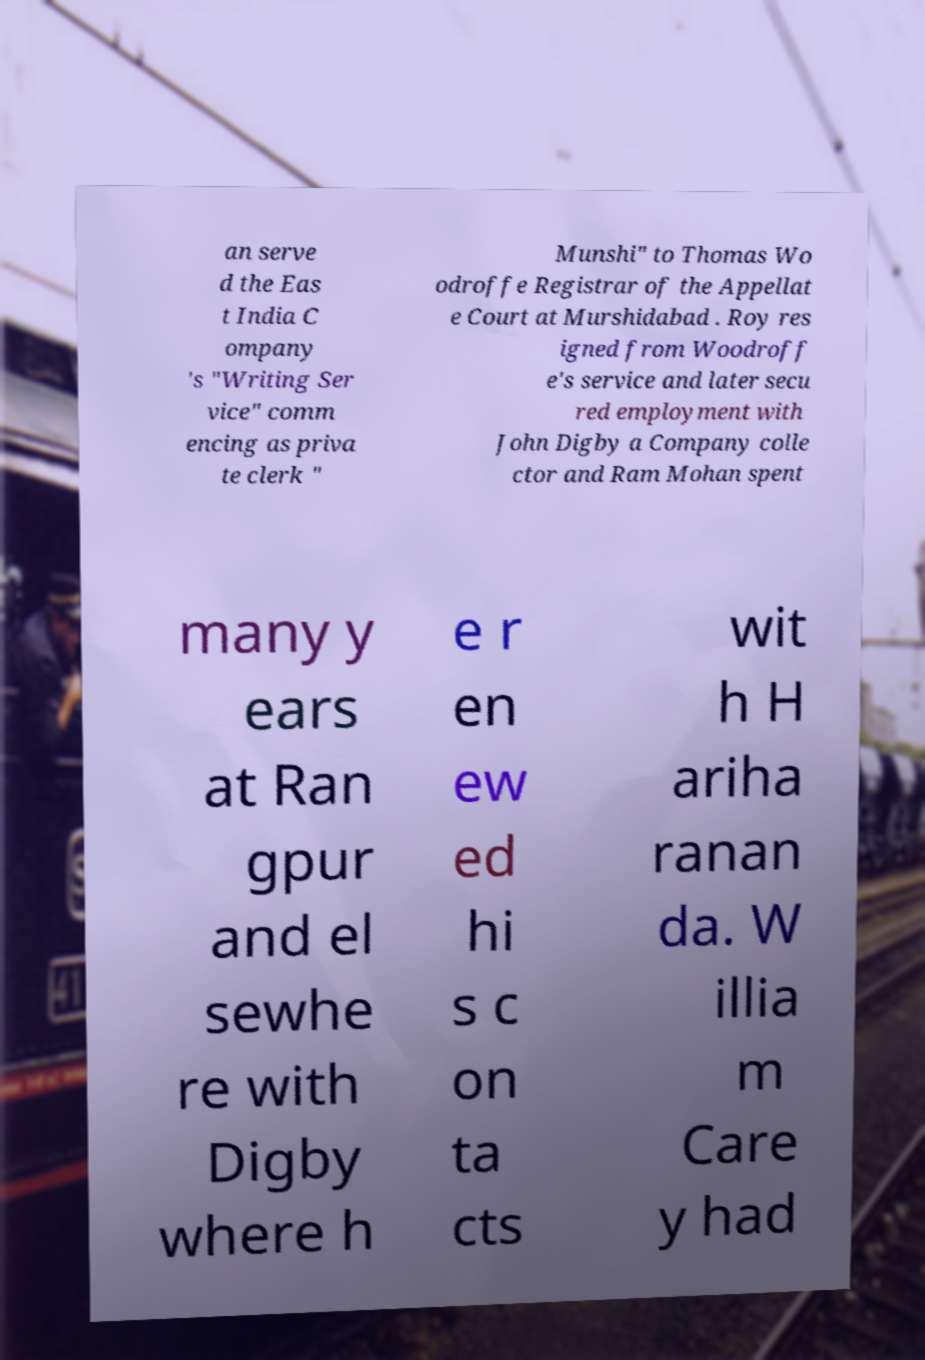Can you read and provide the text displayed in the image?This photo seems to have some interesting text. Can you extract and type it out for me? an serve d the Eas t India C ompany 's "Writing Ser vice" comm encing as priva te clerk " Munshi" to Thomas Wo odroffe Registrar of the Appellat e Court at Murshidabad . Roy res igned from Woodroff e's service and later secu red employment with John Digby a Company colle ctor and Ram Mohan spent many y ears at Ran gpur and el sewhe re with Digby where h e r en ew ed hi s c on ta cts wit h H ariha ranan da. W illia m Care y had 